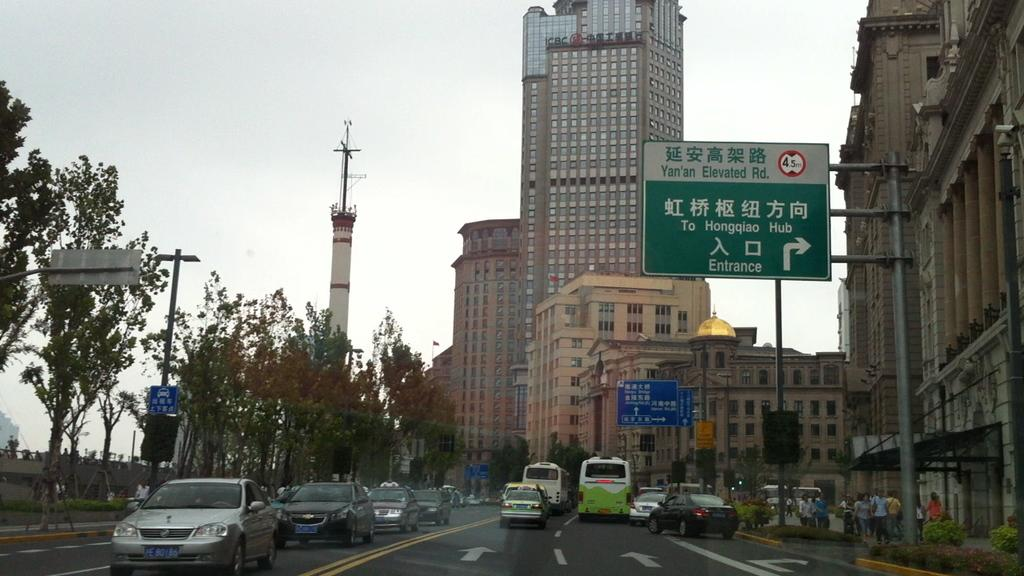What is the main feature of the image? There is a road in the image. What is happening on the road? Vehicles are moving on the road. What other structures can be seen in the image? There is a tower and buildings in the image. What type of vegetation is present in the image? Trees are present in the image. What can be seen in the background of the image? The sky is visible in the background of the image. What type of meat is being transported in the crate on the road? There is no crate or meat present in the image; it only features a road, vehicles, a tower, buildings, trees, and the sky. 